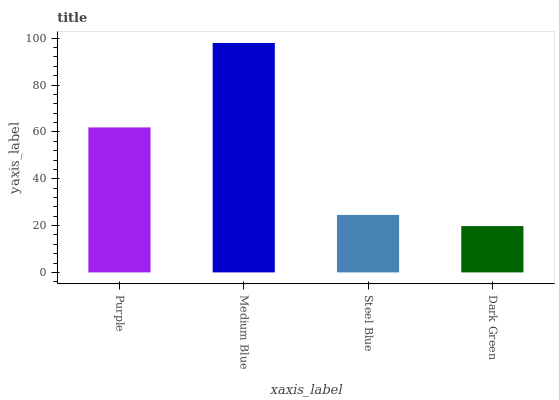Is Steel Blue the minimum?
Answer yes or no. No. Is Steel Blue the maximum?
Answer yes or no. No. Is Medium Blue greater than Steel Blue?
Answer yes or no. Yes. Is Steel Blue less than Medium Blue?
Answer yes or no. Yes. Is Steel Blue greater than Medium Blue?
Answer yes or no. No. Is Medium Blue less than Steel Blue?
Answer yes or no. No. Is Purple the high median?
Answer yes or no. Yes. Is Steel Blue the low median?
Answer yes or no. Yes. Is Dark Green the high median?
Answer yes or no. No. Is Purple the low median?
Answer yes or no. No. 